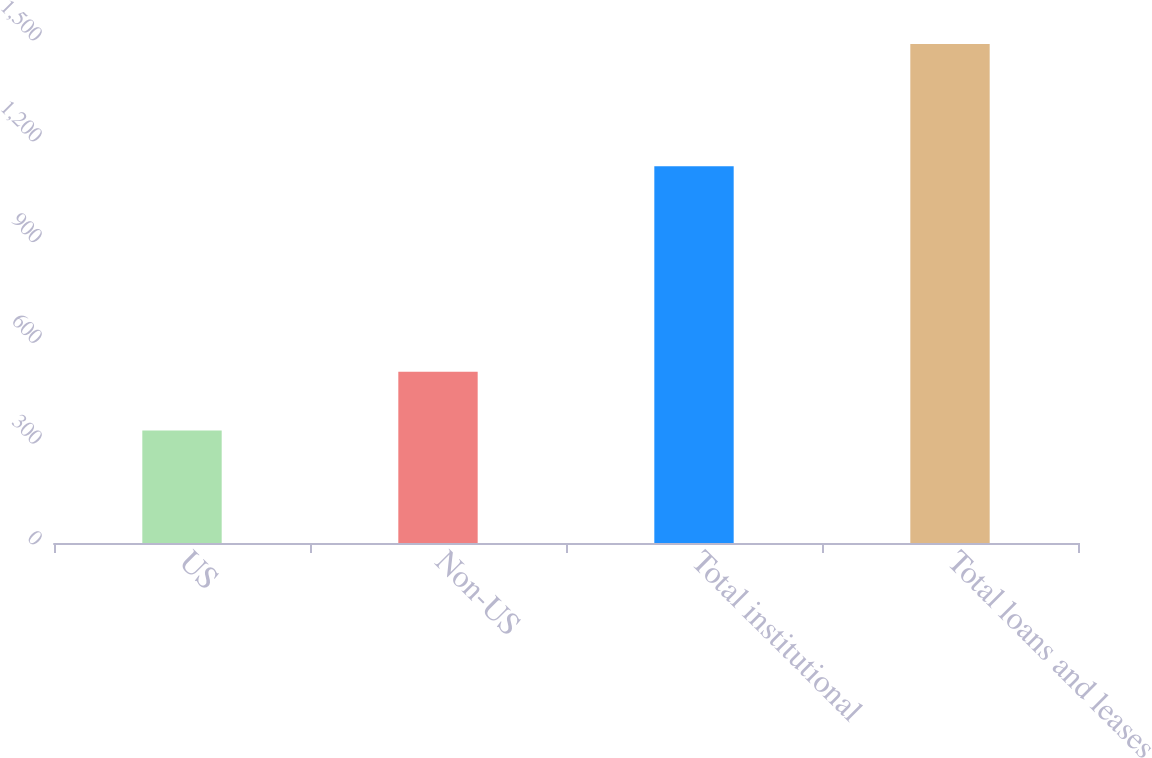Convert chart to OTSL. <chart><loc_0><loc_0><loc_500><loc_500><bar_chart><fcel>US<fcel>Non-US<fcel>Total institutional<fcel>Total loans and leases<nl><fcel>335<fcel>510<fcel>1121<fcel>1485<nl></chart> 